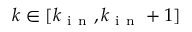<formula> <loc_0><loc_0><loc_500><loc_500>k \in [ k _ { i n } , k _ { i n } + 1 ]</formula> 